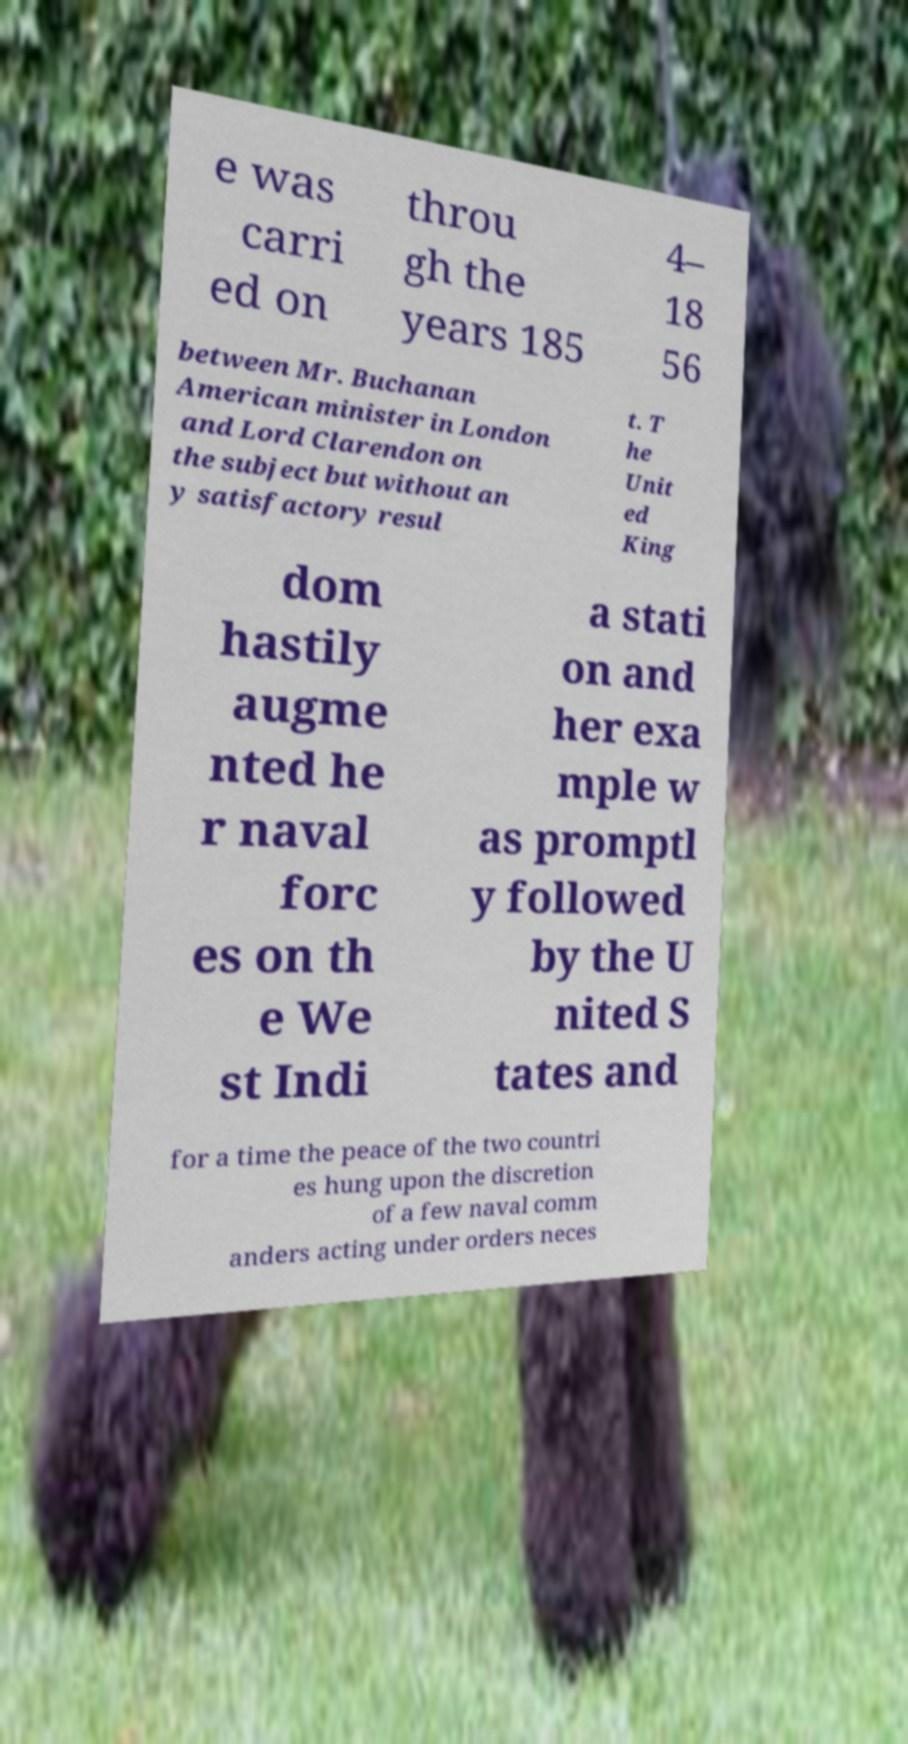What messages or text are displayed in this image? I need them in a readable, typed format. e was carri ed on throu gh the years 185 4– 18 56 between Mr. Buchanan American minister in London and Lord Clarendon on the subject but without an y satisfactory resul t. T he Unit ed King dom hastily augme nted he r naval forc es on th e We st Indi a stati on and her exa mple w as promptl y followed by the U nited S tates and for a time the peace of the two countri es hung upon the discretion of a few naval comm anders acting under orders neces 